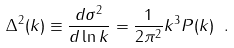Convert formula to latex. <formula><loc_0><loc_0><loc_500><loc_500>\Delta ^ { 2 } ( k ) \equiv \frac { d \sigma ^ { 2 } } { d \ln k } = \frac { 1 } { 2 \pi ^ { 2 } } k ^ { 3 } P ( k ) \ .</formula> 